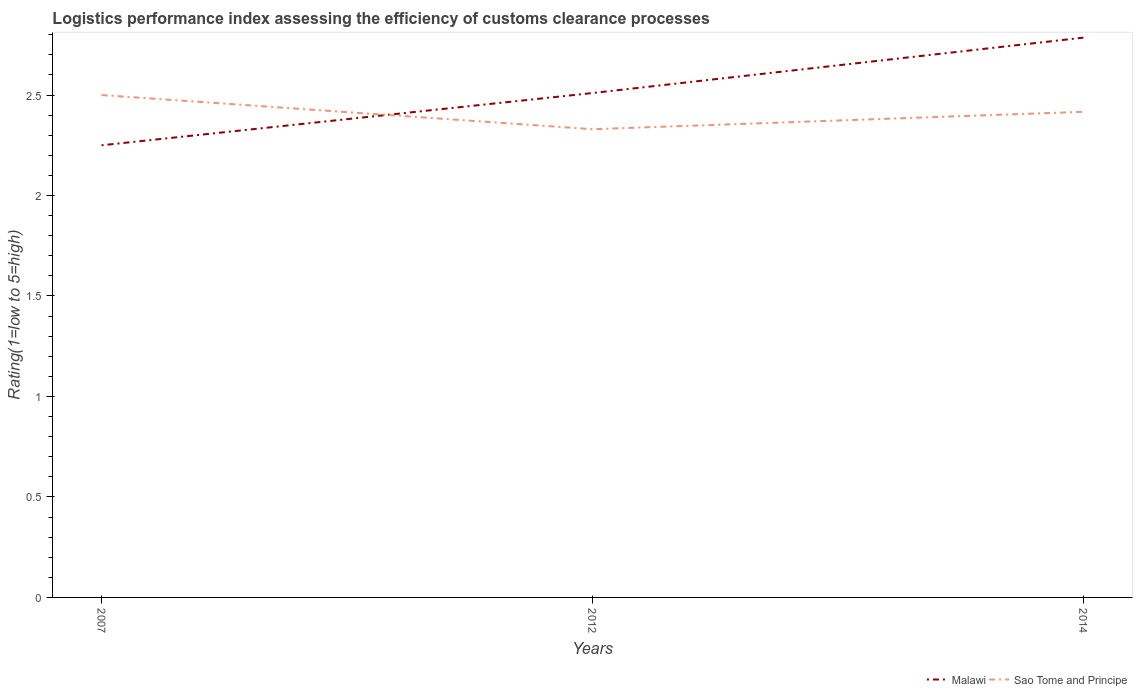Across all years, what is the maximum Logistic performance index in Sao Tome and Principe?
Your answer should be compact. 2.33. What is the total Logistic performance index in Malawi in the graph?
Your answer should be very brief. -0.54. What is the difference between the highest and the second highest Logistic performance index in Sao Tome and Principe?
Your answer should be very brief. 0.17. What is the difference between the highest and the lowest Logistic performance index in Sao Tome and Principe?
Ensure brevity in your answer.  2. Is the Logistic performance index in Malawi strictly greater than the Logistic performance index in Sao Tome and Principe over the years?
Your answer should be compact. No. Does the graph contain any zero values?
Provide a short and direct response. No. Does the graph contain grids?
Provide a short and direct response. No. What is the title of the graph?
Give a very brief answer. Logistics performance index assessing the efficiency of customs clearance processes. What is the label or title of the X-axis?
Provide a short and direct response. Years. What is the label or title of the Y-axis?
Your answer should be very brief. Rating(1=low to 5=high). What is the Rating(1=low to 5=high) in Malawi in 2007?
Your answer should be compact. 2.25. What is the Rating(1=low to 5=high) in Malawi in 2012?
Keep it short and to the point. 2.51. What is the Rating(1=low to 5=high) of Sao Tome and Principe in 2012?
Keep it short and to the point. 2.33. What is the Rating(1=low to 5=high) in Malawi in 2014?
Your answer should be very brief. 2.79. What is the Rating(1=low to 5=high) in Sao Tome and Principe in 2014?
Your response must be concise. 2.42. Across all years, what is the maximum Rating(1=low to 5=high) in Malawi?
Offer a terse response. 2.79. Across all years, what is the maximum Rating(1=low to 5=high) in Sao Tome and Principe?
Offer a very short reply. 2.5. Across all years, what is the minimum Rating(1=low to 5=high) in Malawi?
Give a very brief answer. 2.25. Across all years, what is the minimum Rating(1=low to 5=high) in Sao Tome and Principe?
Provide a short and direct response. 2.33. What is the total Rating(1=low to 5=high) of Malawi in the graph?
Your answer should be very brief. 7.55. What is the total Rating(1=low to 5=high) in Sao Tome and Principe in the graph?
Your response must be concise. 7.25. What is the difference between the Rating(1=low to 5=high) of Malawi in 2007 and that in 2012?
Ensure brevity in your answer.  -0.26. What is the difference between the Rating(1=low to 5=high) of Sao Tome and Principe in 2007 and that in 2012?
Provide a short and direct response. 0.17. What is the difference between the Rating(1=low to 5=high) of Malawi in 2007 and that in 2014?
Offer a very short reply. -0.54. What is the difference between the Rating(1=low to 5=high) in Sao Tome and Principe in 2007 and that in 2014?
Offer a very short reply. 0.08. What is the difference between the Rating(1=low to 5=high) in Malawi in 2012 and that in 2014?
Offer a very short reply. -0.28. What is the difference between the Rating(1=low to 5=high) in Sao Tome and Principe in 2012 and that in 2014?
Offer a terse response. -0.09. What is the difference between the Rating(1=low to 5=high) in Malawi in 2007 and the Rating(1=low to 5=high) in Sao Tome and Principe in 2012?
Give a very brief answer. -0.08. What is the difference between the Rating(1=low to 5=high) of Malawi in 2007 and the Rating(1=low to 5=high) of Sao Tome and Principe in 2014?
Provide a succinct answer. -0.17. What is the difference between the Rating(1=low to 5=high) in Malawi in 2012 and the Rating(1=low to 5=high) in Sao Tome and Principe in 2014?
Provide a succinct answer. 0.09. What is the average Rating(1=low to 5=high) of Malawi per year?
Offer a very short reply. 2.52. What is the average Rating(1=low to 5=high) of Sao Tome and Principe per year?
Your answer should be compact. 2.42. In the year 2012, what is the difference between the Rating(1=low to 5=high) in Malawi and Rating(1=low to 5=high) in Sao Tome and Principe?
Provide a short and direct response. 0.18. In the year 2014, what is the difference between the Rating(1=low to 5=high) in Malawi and Rating(1=low to 5=high) in Sao Tome and Principe?
Offer a very short reply. 0.37. What is the ratio of the Rating(1=low to 5=high) of Malawi in 2007 to that in 2012?
Provide a succinct answer. 0.9. What is the ratio of the Rating(1=low to 5=high) of Sao Tome and Principe in 2007 to that in 2012?
Your answer should be compact. 1.07. What is the ratio of the Rating(1=low to 5=high) of Malawi in 2007 to that in 2014?
Offer a terse response. 0.81. What is the ratio of the Rating(1=low to 5=high) of Sao Tome and Principe in 2007 to that in 2014?
Ensure brevity in your answer.  1.03. What is the ratio of the Rating(1=low to 5=high) of Malawi in 2012 to that in 2014?
Provide a succinct answer. 0.9. What is the ratio of the Rating(1=low to 5=high) in Sao Tome and Principe in 2012 to that in 2014?
Provide a succinct answer. 0.96. What is the difference between the highest and the second highest Rating(1=low to 5=high) in Malawi?
Keep it short and to the point. 0.28. What is the difference between the highest and the second highest Rating(1=low to 5=high) in Sao Tome and Principe?
Provide a short and direct response. 0.08. What is the difference between the highest and the lowest Rating(1=low to 5=high) in Malawi?
Offer a very short reply. 0.54. What is the difference between the highest and the lowest Rating(1=low to 5=high) of Sao Tome and Principe?
Ensure brevity in your answer.  0.17. 